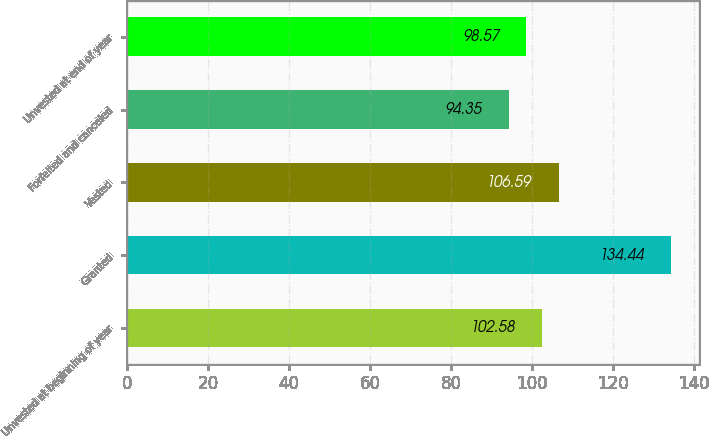<chart> <loc_0><loc_0><loc_500><loc_500><bar_chart><fcel>Unvested at beginning of year<fcel>Granted<fcel>Vested<fcel>Forfeited and canceled<fcel>Unvested at end of year<nl><fcel>102.58<fcel>134.44<fcel>106.59<fcel>94.35<fcel>98.57<nl></chart> 